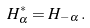Convert formula to latex. <formula><loc_0><loc_0><loc_500><loc_500>H _ { \alpha } ^ { * } = H _ { - \alpha } \, .</formula> 